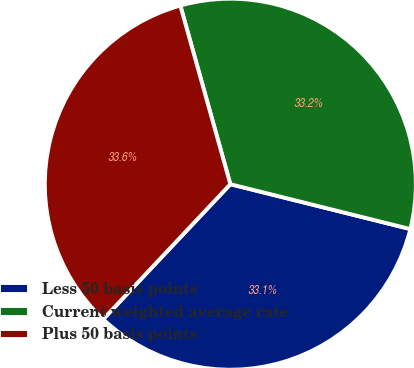<chart> <loc_0><loc_0><loc_500><loc_500><pie_chart><fcel>Less 50 basis points<fcel>Current weighted average rate<fcel>Plus 50 basis points<nl><fcel>33.13%<fcel>33.23%<fcel>33.63%<nl></chart> 